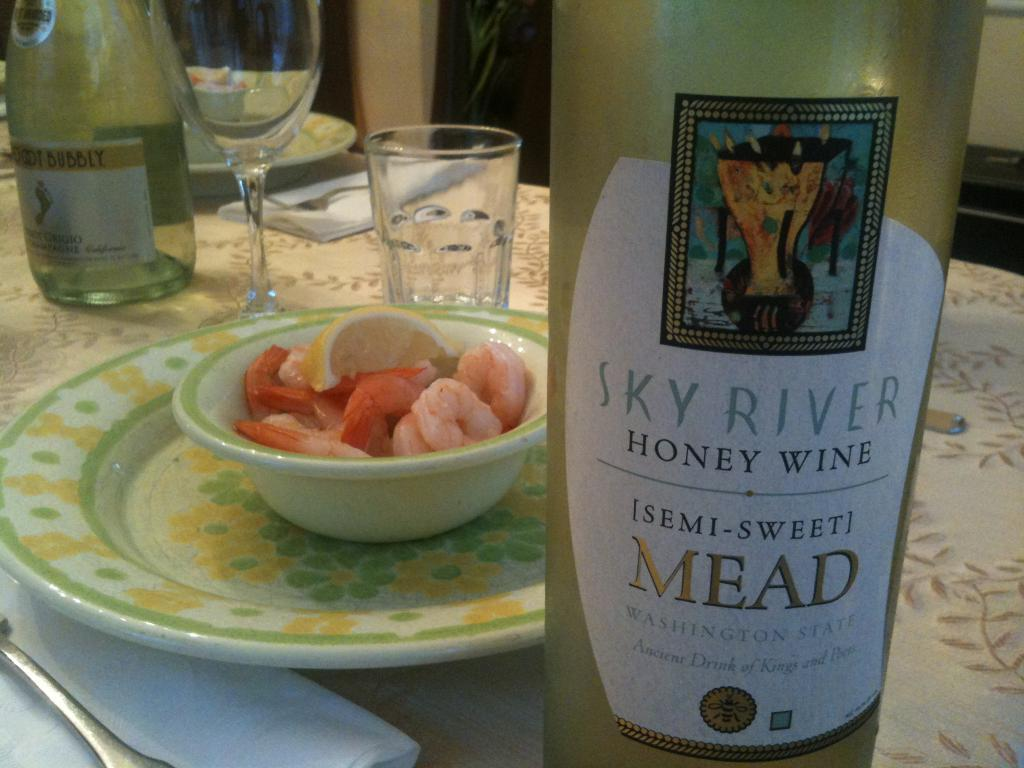<image>
Describe the image concisely. Someone is having Sky River Honey Wine Semi-Sweet Mead with their shrimp. 